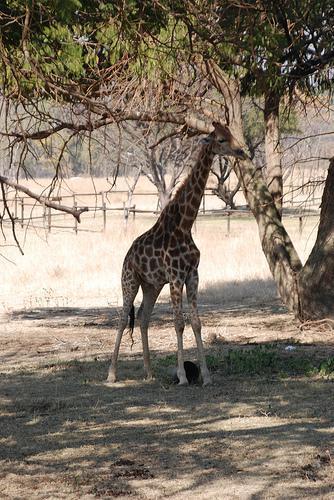How many giraffes are there?
Give a very brief answer. 1. 